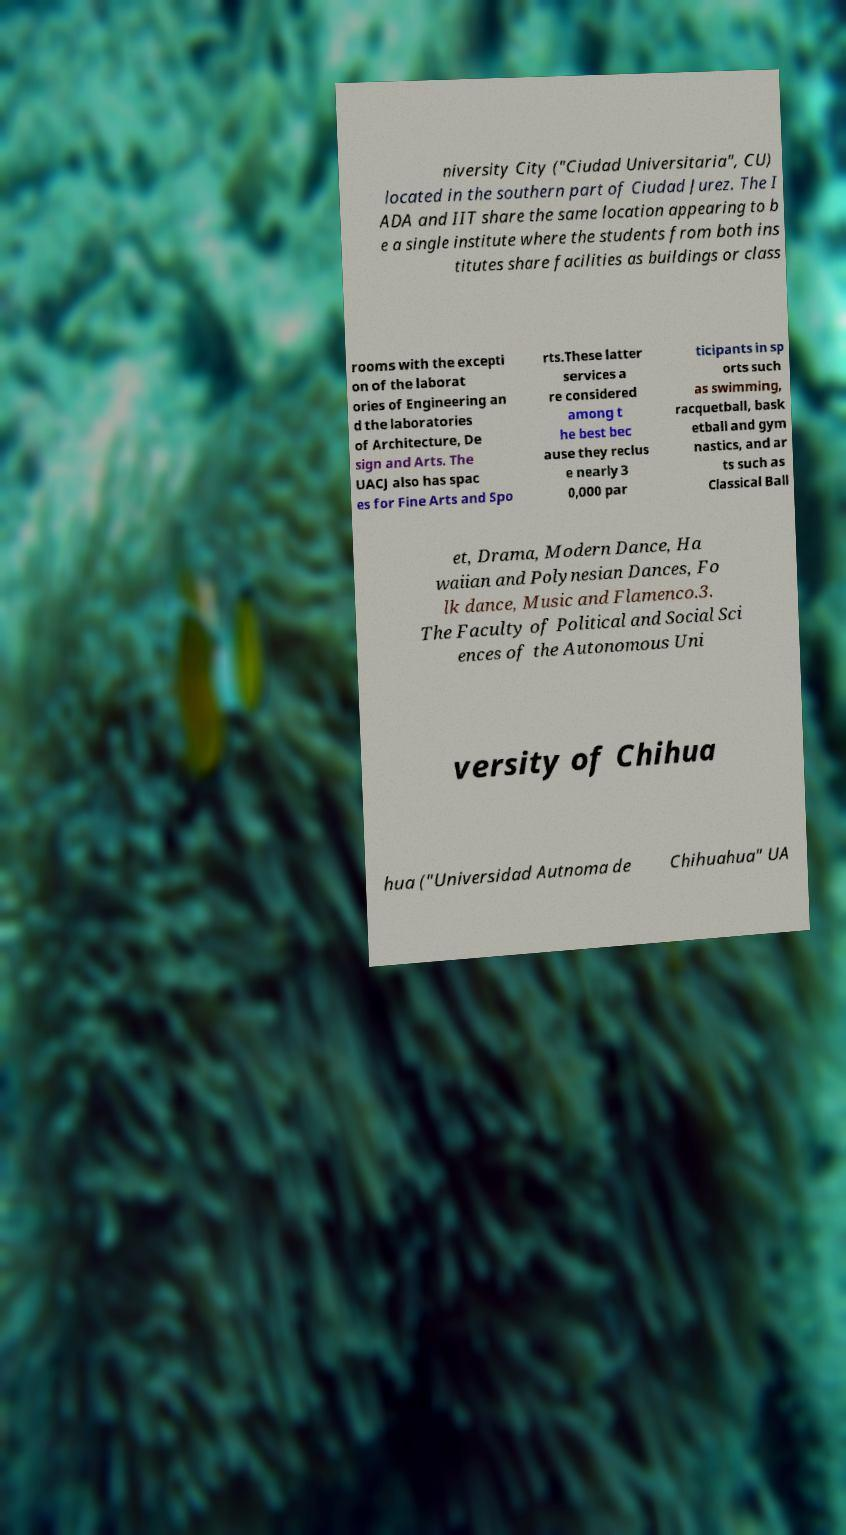Please read and relay the text visible in this image. What does it say? niversity City ("Ciudad Universitaria", CU) located in the southern part of Ciudad Jurez. The I ADA and IIT share the same location appearing to b e a single institute where the students from both ins titutes share facilities as buildings or class rooms with the excepti on of the laborat ories of Engineering an d the laboratories of Architecture, De sign and Arts. The UACJ also has spac es for Fine Arts and Spo rts.These latter services a re considered among t he best bec ause they reclus e nearly 3 0,000 par ticipants in sp orts such as swimming, racquetball, bask etball and gym nastics, and ar ts such as Classical Ball et, Drama, Modern Dance, Ha waiian and Polynesian Dances, Fo lk dance, Music and Flamenco.3. The Faculty of Political and Social Sci ences of the Autonomous Uni versity of Chihua hua ("Universidad Autnoma de Chihuahua" UA 